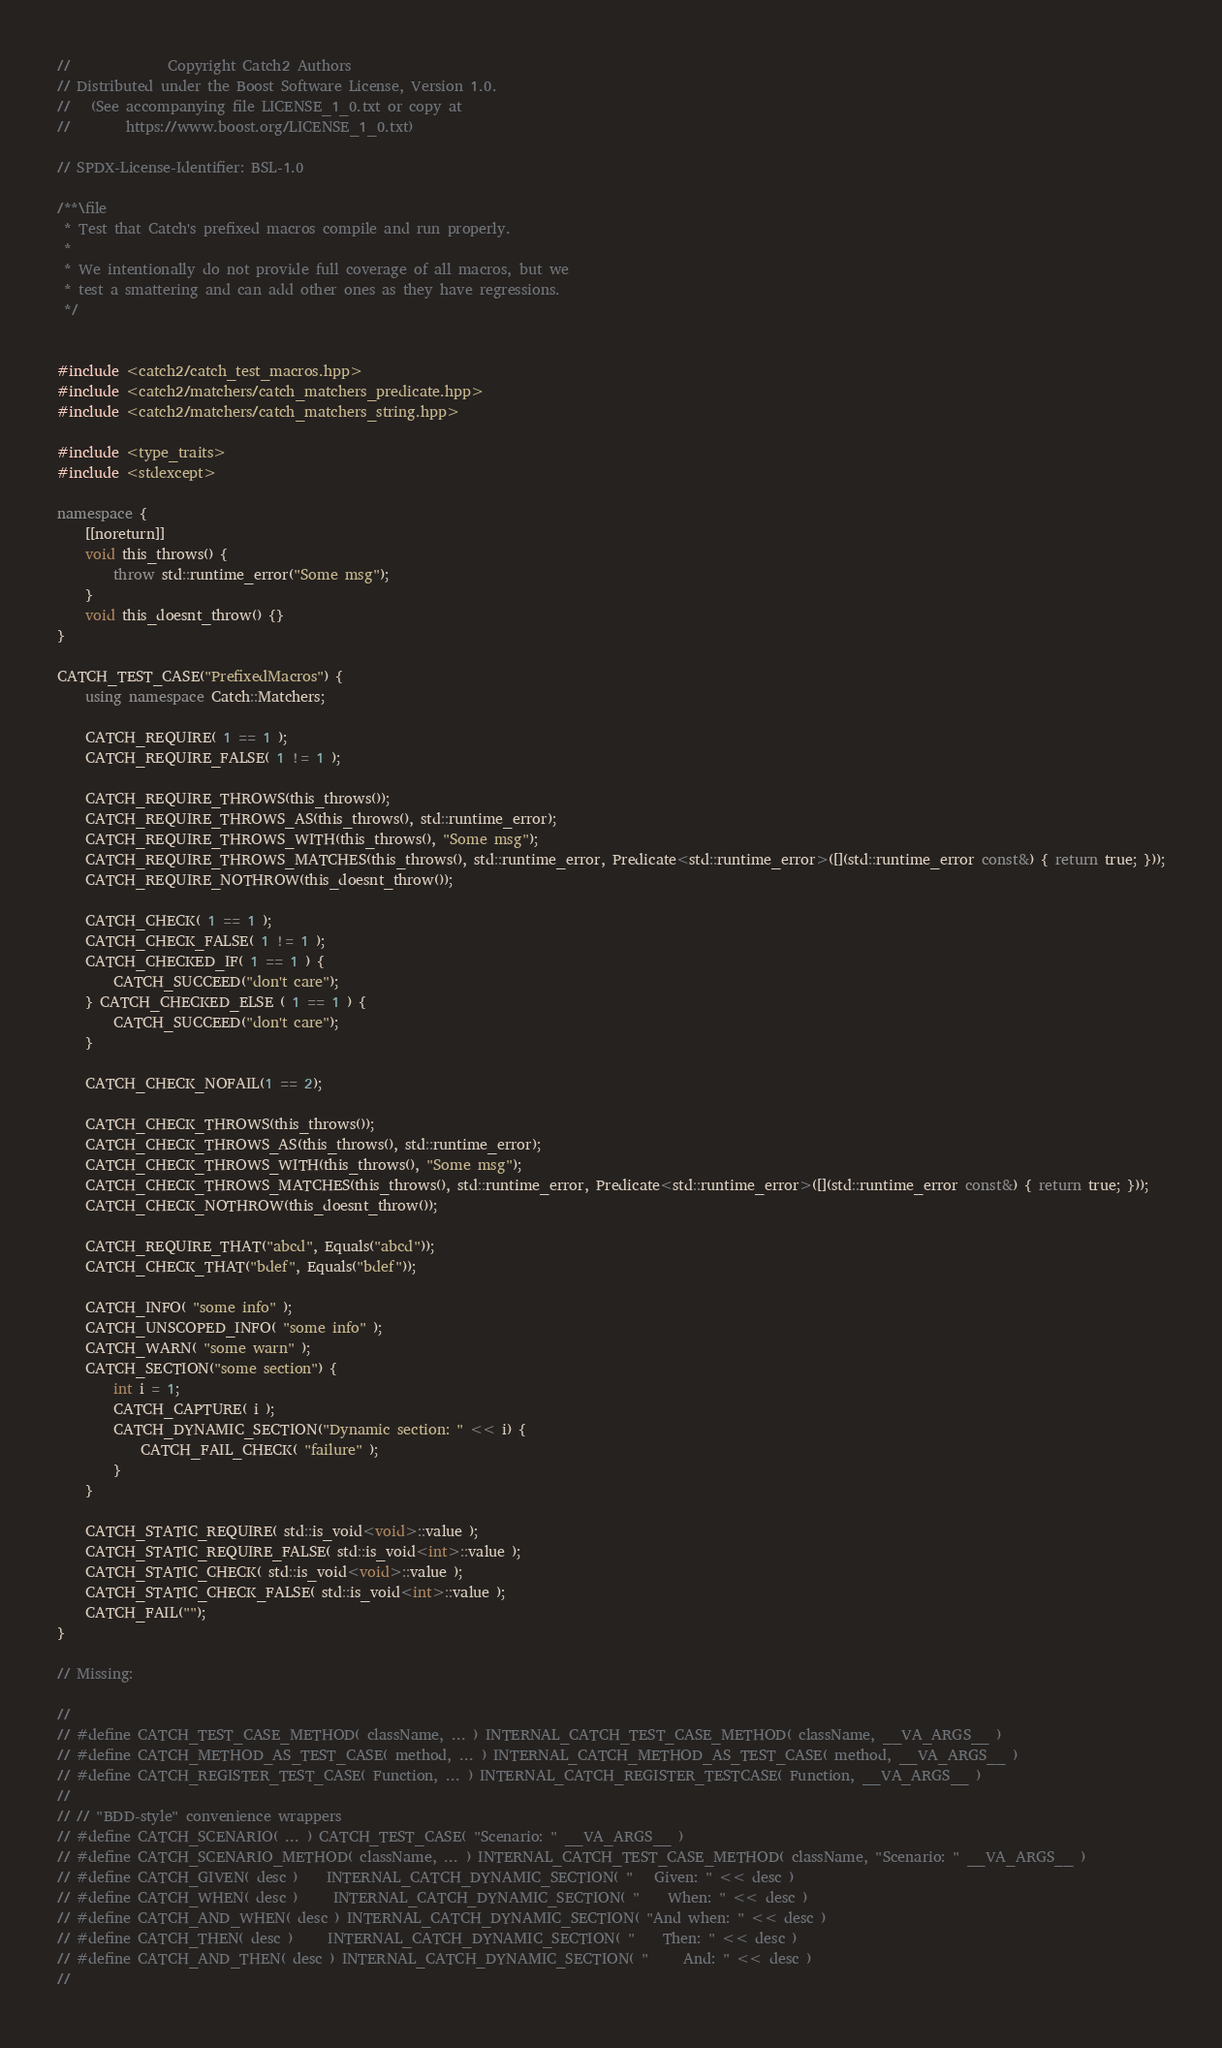<code> <loc_0><loc_0><loc_500><loc_500><_C++_>
//              Copyright Catch2 Authors
// Distributed under the Boost Software License, Version 1.0.
//   (See accompanying file LICENSE_1_0.txt or copy at
//        https://www.boost.org/LICENSE_1_0.txt)

// SPDX-License-Identifier: BSL-1.0

/**\file
 * Test that Catch's prefixed macros compile and run properly.
 *
 * We intentionally do not provide full coverage of all macros, but we
 * test a smattering and can add other ones as they have regressions.
 */


#include <catch2/catch_test_macros.hpp>
#include <catch2/matchers/catch_matchers_predicate.hpp>
#include <catch2/matchers/catch_matchers_string.hpp>

#include <type_traits>
#include <stdexcept>

namespace {
    [[noreturn]]
    void this_throws() {
        throw std::runtime_error("Some msg");
    }
    void this_doesnt_throw() {}
}

CATCH_TEST_CASE("PrefixedMacros") {
    using namespace Catch::Matchers;

    CATCH_REQUIRE( 1 == 1 );
    CATCH_REQUIRE_FALSE( 1 != 1 );

    CATCH_REQUIRE_THROWS(this_throws());
    CATCH_REQUIRE_THROWS_AS(this_throws(), std::runtime_error);
    CATCH_REQUIRE_THROWS_WITH(this_throws(), "Some msg");
    CATCH_REQUIRE_THROWS_MATCHES(this_throws(), std::runtime_error, Predicate<std::runtime_error>([](std::runtime_error const&) { return true; }));
    CATCH_REQUIRE_NOTHROW(this_doesnt_throw());

    CATCH_CHECK( 1 == 1 );
    CATCH_CHECK_FALSE( 1 != 1 );
    CATCH_CHECKED_IF( 1 == 1 ) {
        CATCH_SUCCEED("don't care");
    } CATCH_CHECKED_ELSE ( 1 == 1 ) {
        CATCH_SUCCEED("don't care");
    }

    CATCH_CHECK_NOFAIL(1 == 2);

    CATCH_CHECK_THROWS(this_throws());
    CATCH_CHECK_THROWS_AS(this_throws(), std::runtime_error);
    CATCH_CHECK_THROWS_WITH(this_throws(), "Some msg");
    CATCH_CHECK_THROWS_MATCHES(this_throws(), std::runtime_error, Predicate<std::runtime_error>([](std::runtime_error const&) { return true; }));
    CATCH_CHECK_NOTHROW(this_doesnt_throw());

    CATCH_REQUIRE_THAT("abcd", Equals("abcd"));
    CATCH_CHECK_THAT("bdef", Equals("bdef"));

    CATCH_INFO( "some info" );
    CATCH_UNSCOPED_INFO( "some info" );
    CATCH_WARN( "some warn" );
    CATCH_SECTION("some section") {
        int i = 1;
        CATCH_CAPTURE( i );
        CATCH_DYNAMIC_SECTION("Dynamic section: " << i) {
            CATCH_FAIL_CHECK( "failure" );
        }
    }

    CATCH_STATIC_REQUIRE( std::is_void<void>::value );
    CATCH_STATIC_REQUIRE_FALSE( std::is_void<int>::value );
    CATCH_STATIC_CHECK( std::is_void<void>::value );
    CATCH_STATIC_CHECK_FALSE( std::is_void<int>::value );
    CATCH_FAIL("");
}

// Missing:

//
// #define CATCH_TEST_CASE_METHOD( className, ... ) INTERNAL_CATCH_TEST_CASE_METHOD( className, __VA_ARGS__ )
// #define CATCH_METHOD_AS_TEST_CASE( method, ... ) INTERNAL_CATCH_METHOD_AS_TEST_CASE( method, __VA_ARGS__ )
// #define CATCH_REGISTER_TEST_CASE( Function, ... ) INTERNAL_CATCH_REGISTER_TESTCASE( Function, __VA_ARGS__ )
//
// // "BDD-style" convenience wrappers
// #define CATCH_SCENARIO( ... ) CATCH_TEST_CASE( "Scenario: " __VA_ARGS__ )
// #define CATCH_SCENARIO_METHOD( className, ... ) INTERNAL_CATCH_TEST_CASE_METHOD( className, "Scenario: " __VA_ARGS__ )
// #define CATCH_GIVEN( desc )    INTERNAL_CATCH_DYNAMIC_SECTION( "   Given: " << desc )
// #define CATCH_WHEN( desc )     INTERNAL_CATCH_DYNAMIC_SECTION( "    When: " << desc )
// #define CATCH_AND_WHEN( desc ) INTERNAL_CATCH_DYNAMIC_SECTION( "And when: " << desc )
// #define CATCH_THEN( desc )     INTERNAL_CATCH_DYNAMIC_SECTION( "    Then: " << desc )
// #define CATCH_AND_THEN( desc ) INTERNAL_CATCH_DYNAMIC_SECTION( "     And: " << desc )
//
</code> 